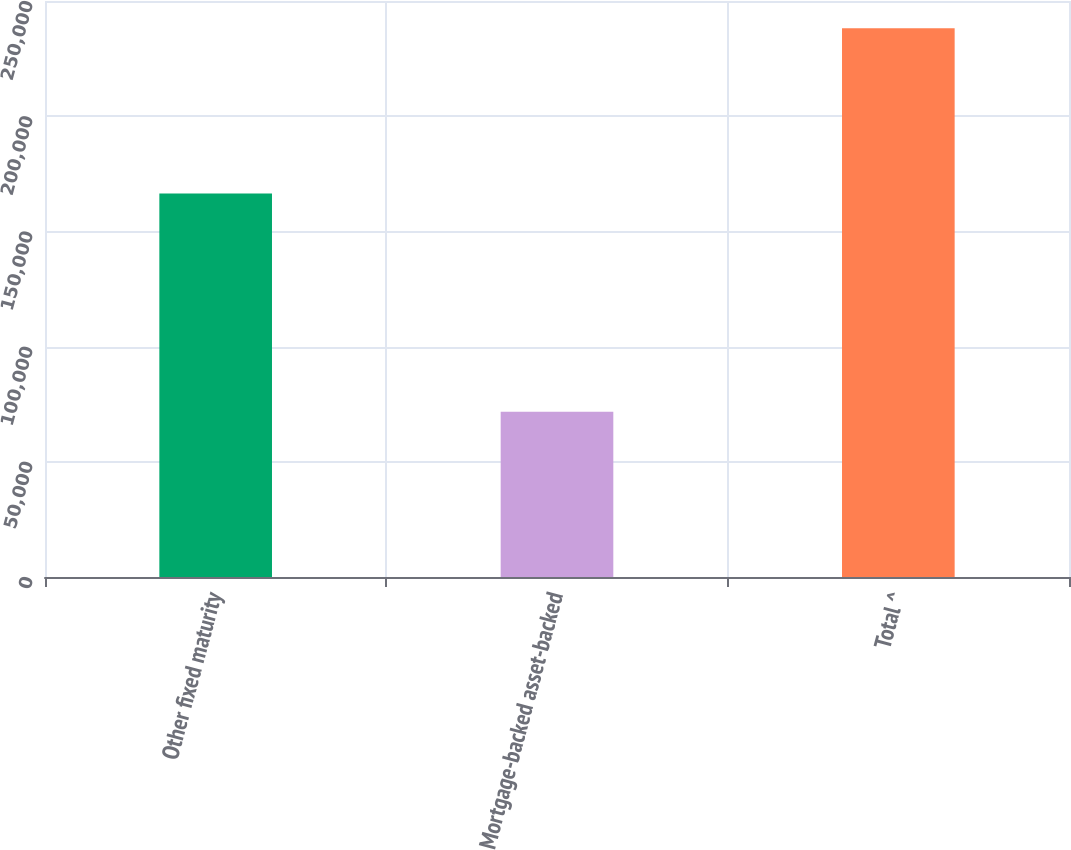<chart> <loc_0><loc_0><loc_500><loc_500><bar_chart><fcel>Other fixed maturity<fcel>Mortgage-backed asset-backed<fcel>Total ^<nl><fcel>166413<fcel>71763<fcel>238176<nl></chart> 